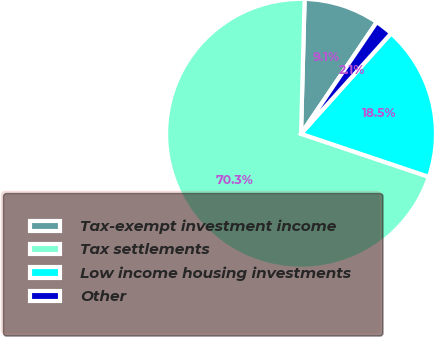Convert chart. <chart><loc_0><loc_0><loc_500><loc_500><pie_chart><fcel>Tax-exempt investment income<fcel>Tax settlements<fcel>Low income housing investments<fcel>Other<nl><fcel>9.06%<fcel>70.26%<fcel>18.54%<fcel>2.15%<nl></chart> 